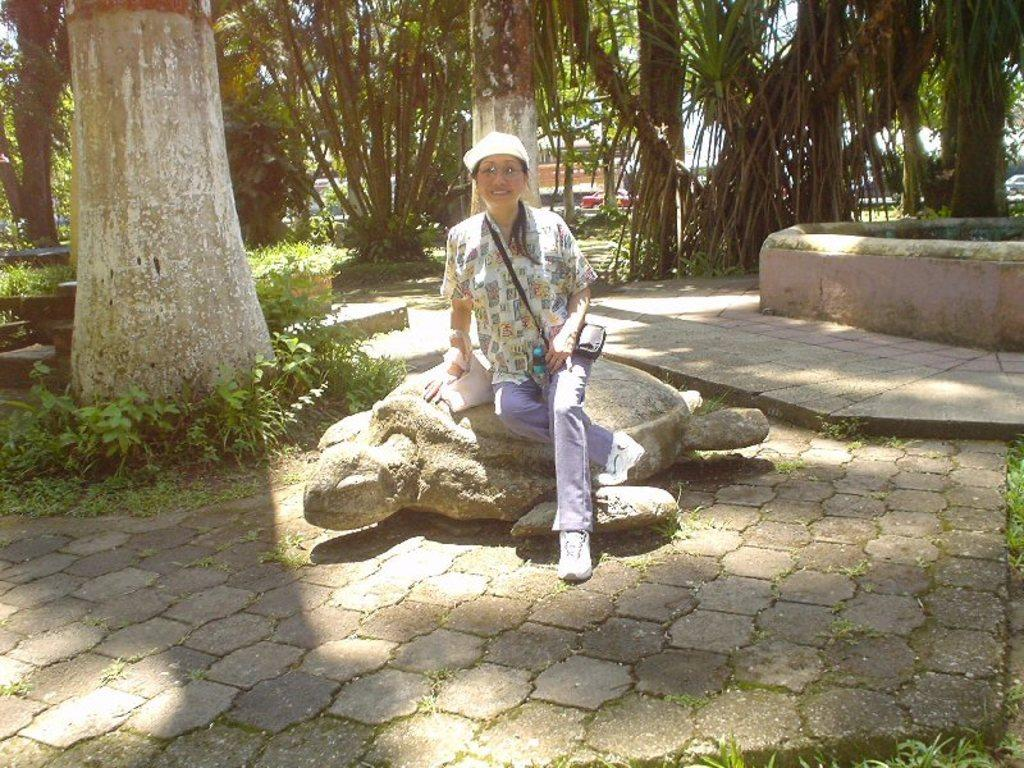What is the woman sitting on in the image? The woman is sitting on a statue of a turtle. What type of clothing is the woman wearing on her upper body? The woman is wearing a shirt. What type of clothing is the woman wearing on her lower body? The woman is wearing trousers. What type of footwear is the woman wearing? The woman is wearing shoes. What type of headwear is the woman wearing? The woman is wearing a cap. What can be seen in the background of the image? There are trees visible in the background of the image. What type of stamp can be seen on the woman's shirt in the image? There is no stamp visible on the woman's shirt in the image. What type of trade is the woman engaged in while sitting on the statue of a turtle? There is no indication of any trade or occupation in the image; the woman is simply sitting on the statue. 